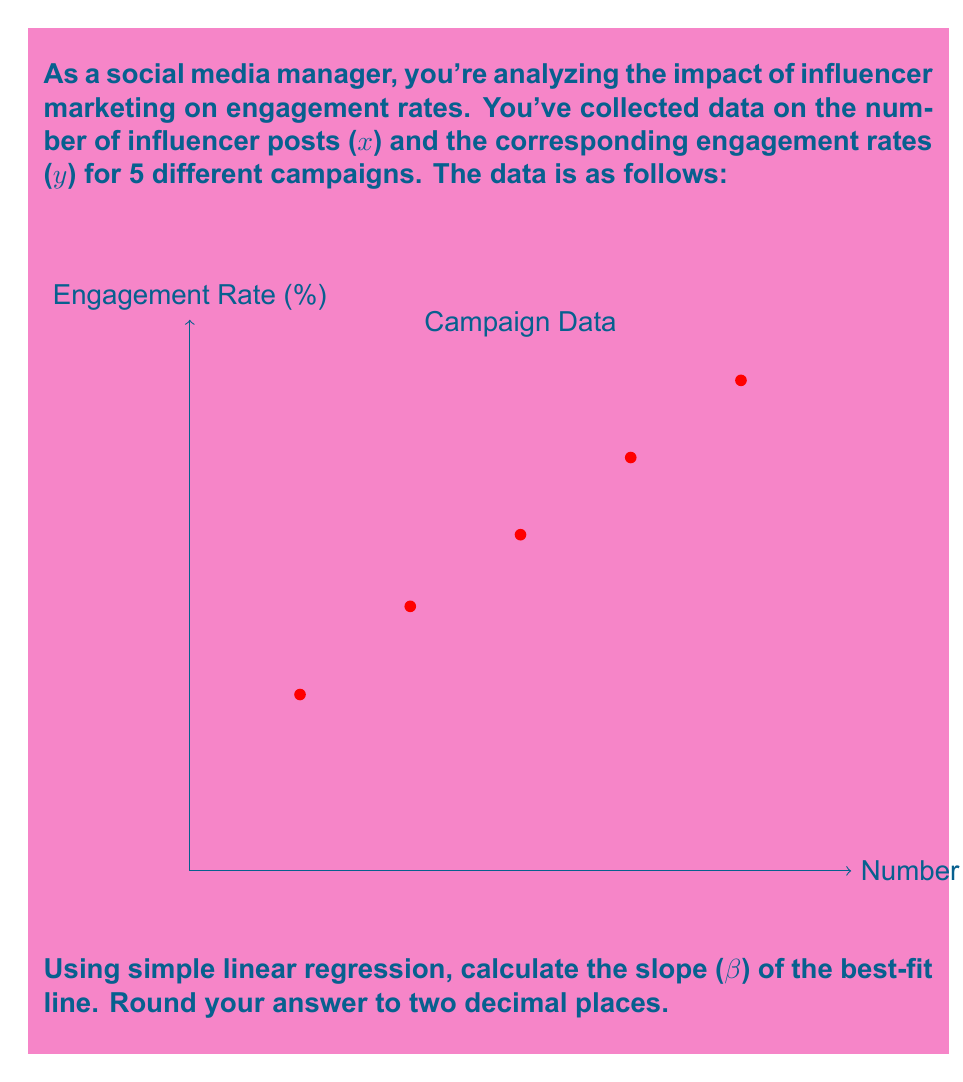Provide a solution to this math problem. To calculate the slope (β) of the best-fit line using simple linear regression, we'll use the formula:

$$ \beta = \frac{n\sum xy - \sum x \sum y}{n\sum x^2 - (\sum x)^2} $$

Where n is the number of data points, x is the number of influencer posts, and y is the engagement rate.

Step 1: Calculate the required sums:
n = 5
Σx = 2 + 4 + 6 + 8 + 10 = 30
Σy = 3.2 + 4.8 + 6.1 + 7.5 + 8.9 = 30.5
Σxy = (2)(3.2) + (4)(4.8) + (6)(6.1) + (8)(7.5) + (10)(8.9) = 245.4
Σx² = 2² + 4² + 6² + 8² + 10² = 220

Step 2: Apply the formula:

$$ \beta = \frac{5(245.4) - (30)(30.5)}{5(220) - (30)^2} $$

Step 3: Simplify:

$$ \beta = \frac{1227 - 915}{1100 - 900} $$

$$ \beta = \frac{312}{200} = 1.56 $$

Step 4: Round to two decimal places:
β ≈ 1.56
Answer: 1.56 